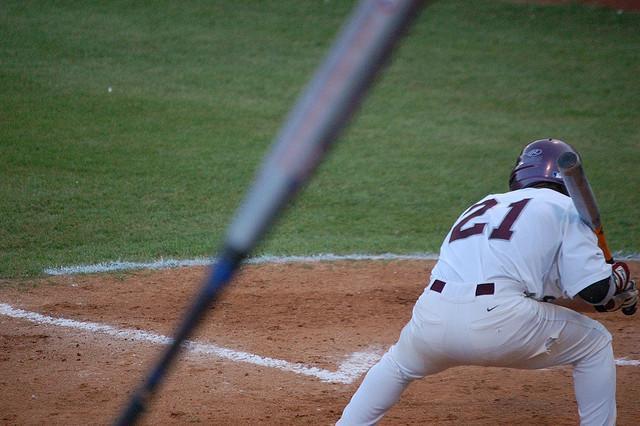How many bats do you see?
Give a very brief answer. 2. How many baseball bats are there?
Give a very brief answer. 2. How many bottles is the lady touching?
Give a very brief answer. 0. 